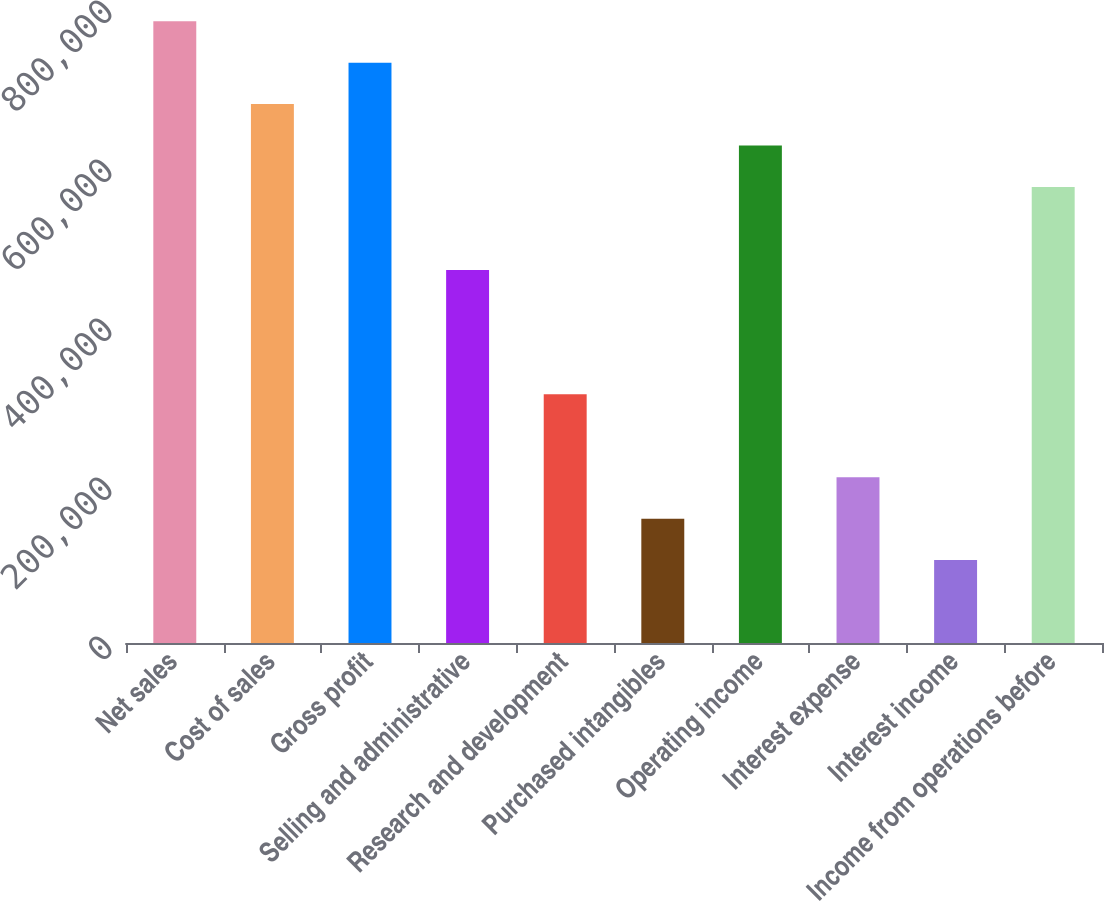Convert chart. <chart><loc_0><loc_0><loc_500><loc_500><bar_chart><fcel>Net sales<fcel>Cost of sales<fcel>Gross profit<fcel>Selling and administrative<fcel>Research and development<fcel>Purchased intangibles<fcel>Operating income<fcel>Interest expense<fcel>Interest income<fcel>Income from operations before<nl><fcel>782129<fcel>677846<fcel>729987<fcel>469278<fcel>312853<fcel>156427<fcel>625704<fcel>208569<fcel>104285<fcel>573562<nl></chart> 